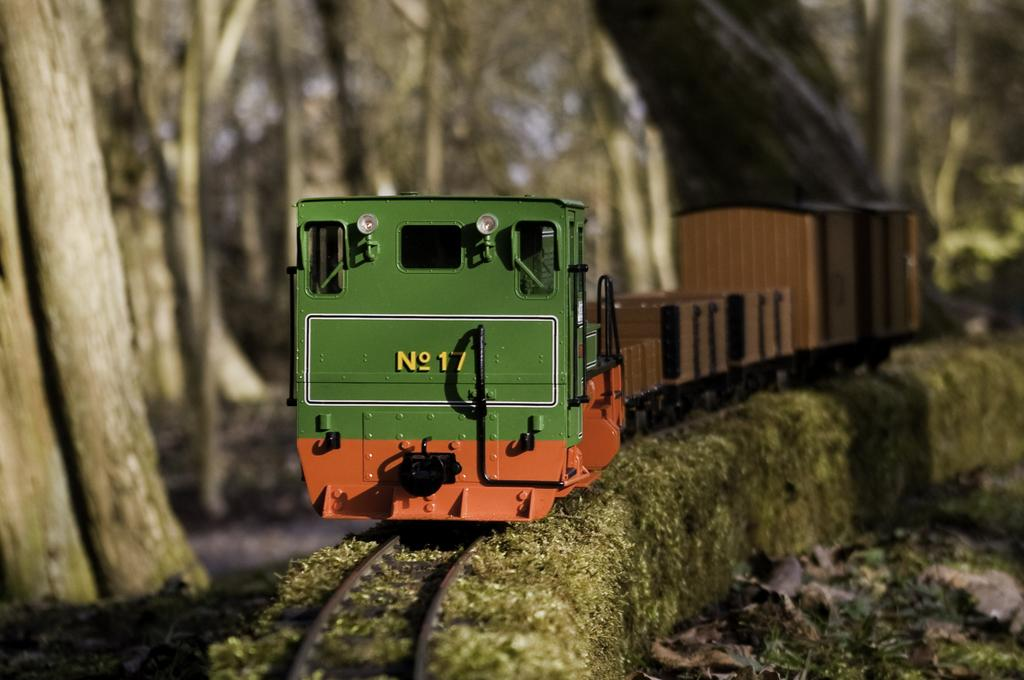What is the main subject of the image? The main subject of the image is a toy train. Where is the toy train located in the image? The toy train is on a railway track. What can be seen in the background of the image? There are trees, plants, and the sky visible in the background of the image. What color are the eyes of the uncle in the image? There is no uncle present in the image, and therefore no eyes to describe. 